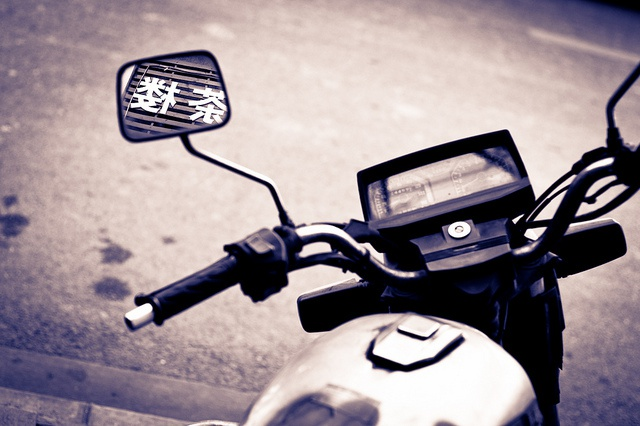Describe the objects in this image and their specific colors. I can see a motorcycle in gray, black, white, purple, and navy tones in this image. 